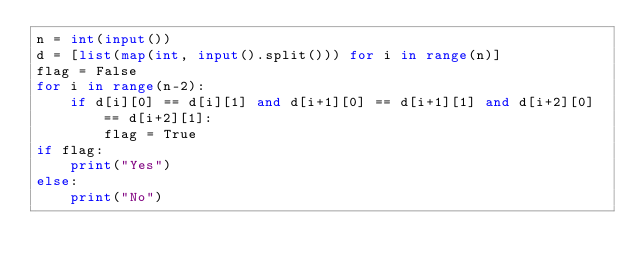<code> <loc_0><loc_0><loc_500><loc_500><_Python_>n = int(input())
d = [list(map(int, input().split())) for i in range(n)]
flag = False
for i in range(n-2):
    if d[i][0] == d[i][1] and d[i+1][0] == d[i+1][1] and d[i+2][0] == d[i+2][1]:
        flag = True
if flag:
    print("Yes")
else:
    print("No")</code> 